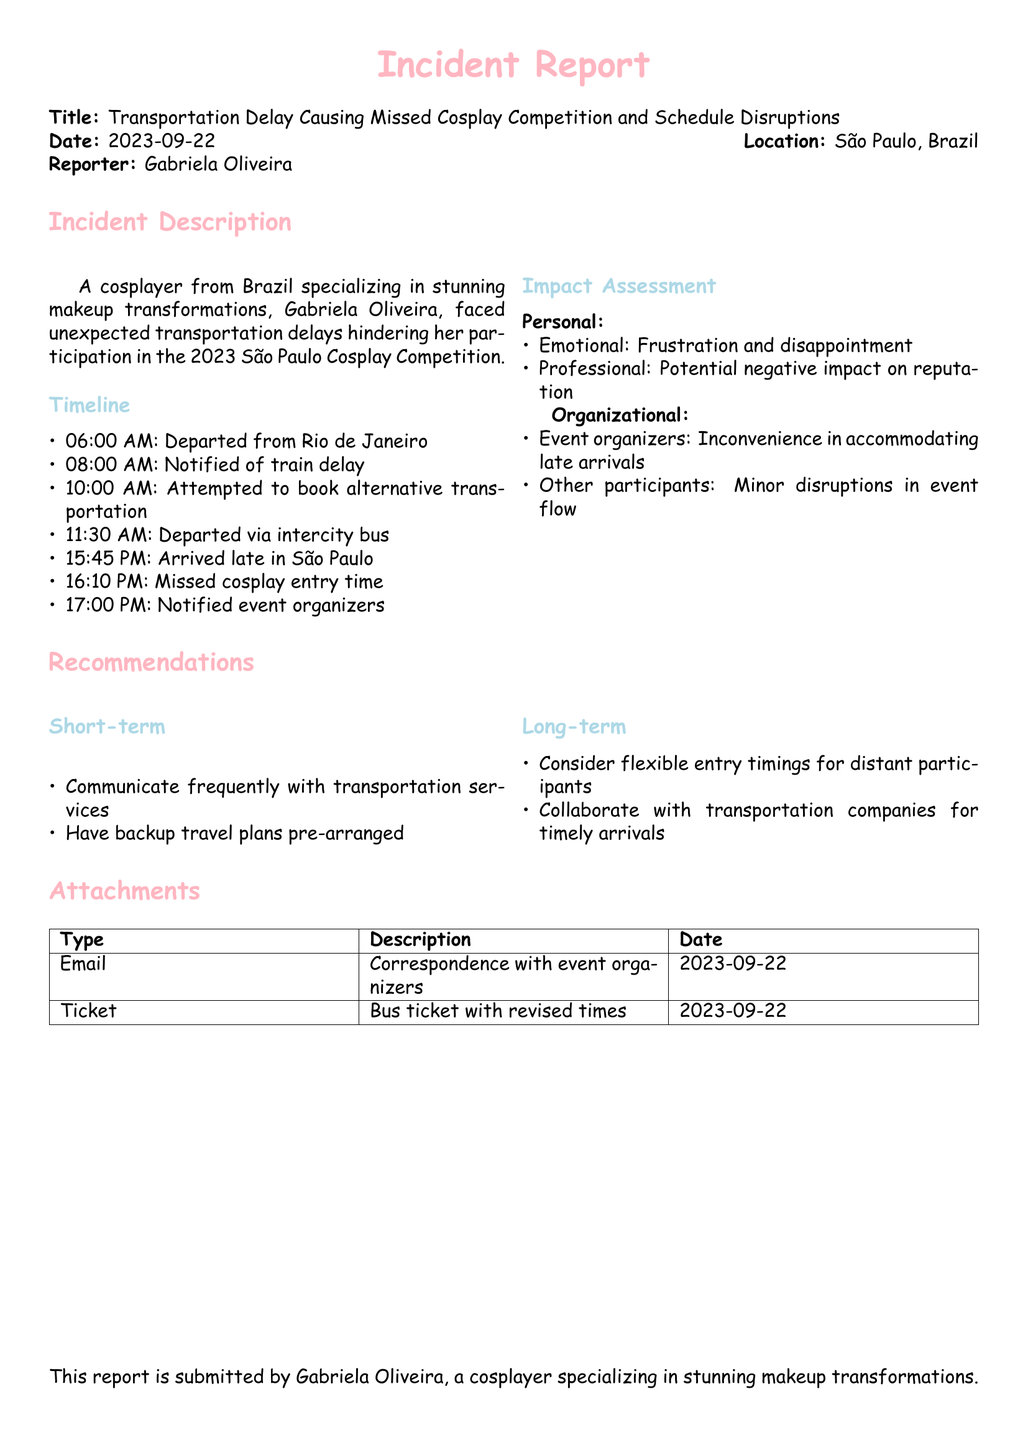What is the date of the incident? The date of the incident is specifically mentioned in the document header.
Answer: 2023-09-22 Who reported the incident? The report states the name of the individual who submitted it at the beginning under 'Reporter'.
Answer: Gabriela Oliveira What time did Gabriela depart from Rio de Janeiro? The timeline provides specific departure times.
Answer: 06:00 AM What mode of transportation was used after the train delay? The incident report mentions the alternative transportation utilized.
Answer: Intercity bus What emotion did Gabriela experience due to the incident? The document includes a personal impact assessment listing specific emotions.
Answer: Frustration What recommendation is made for short-term improvements? The recommendations section outlines short-term strategies to prevent similar issues.
Answer: Communicate frequently with transportation services How did the transportation delay affect other participants? The impact assessment includes effects on other event participants.
Answer: Minor disruptions in event flow What type of document is this? The title explicitly indicates the nature of the document being discussed.
Answer: Incident Report What was the arrival time in São Paulo? The timeline specifies the time of arrival at the destination.
Answer: 15:45 PM 